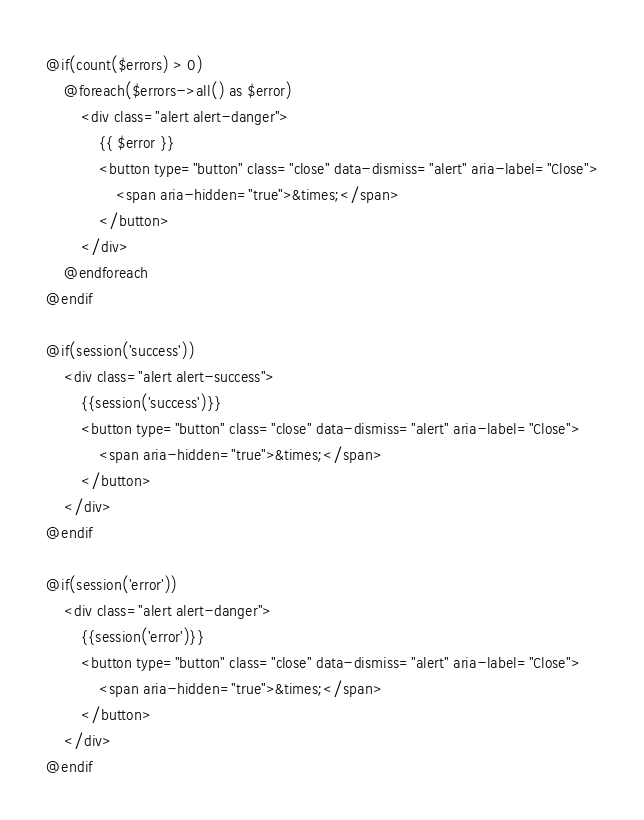<code> <loc_0><loc_0><loc_500><loc_500><_PHP_>@if(count($errors) > 0)
    @foreach($errors->all() as $error)
        <div class="alert alert-danger">
            {{ $error }}
            <button type="button" class="close" data-dismiss="alert" aria-label="Close">
                <span aria-hidden="true">&times;</span>
            </button>
        </div>
    @endforeach
@endif

@if(session('success'))
    <div class="alert alert-success">
        {{session('success')}}
        <button type="button" class="close" data-dismiss="alert" aria-label="Close">
            <span aria-hidden="true">&times;</span>
        </button>
    </div>
@endif

@if(session('error'))
    <div class="alert alert-danger">
        {{session('error')}}
        <button type="button" class="close" data-dismiss="alert" aria-label="Close">
            <span aria-hidden="true">&times;</span>
        </button>
    </div>
@endif</code> 